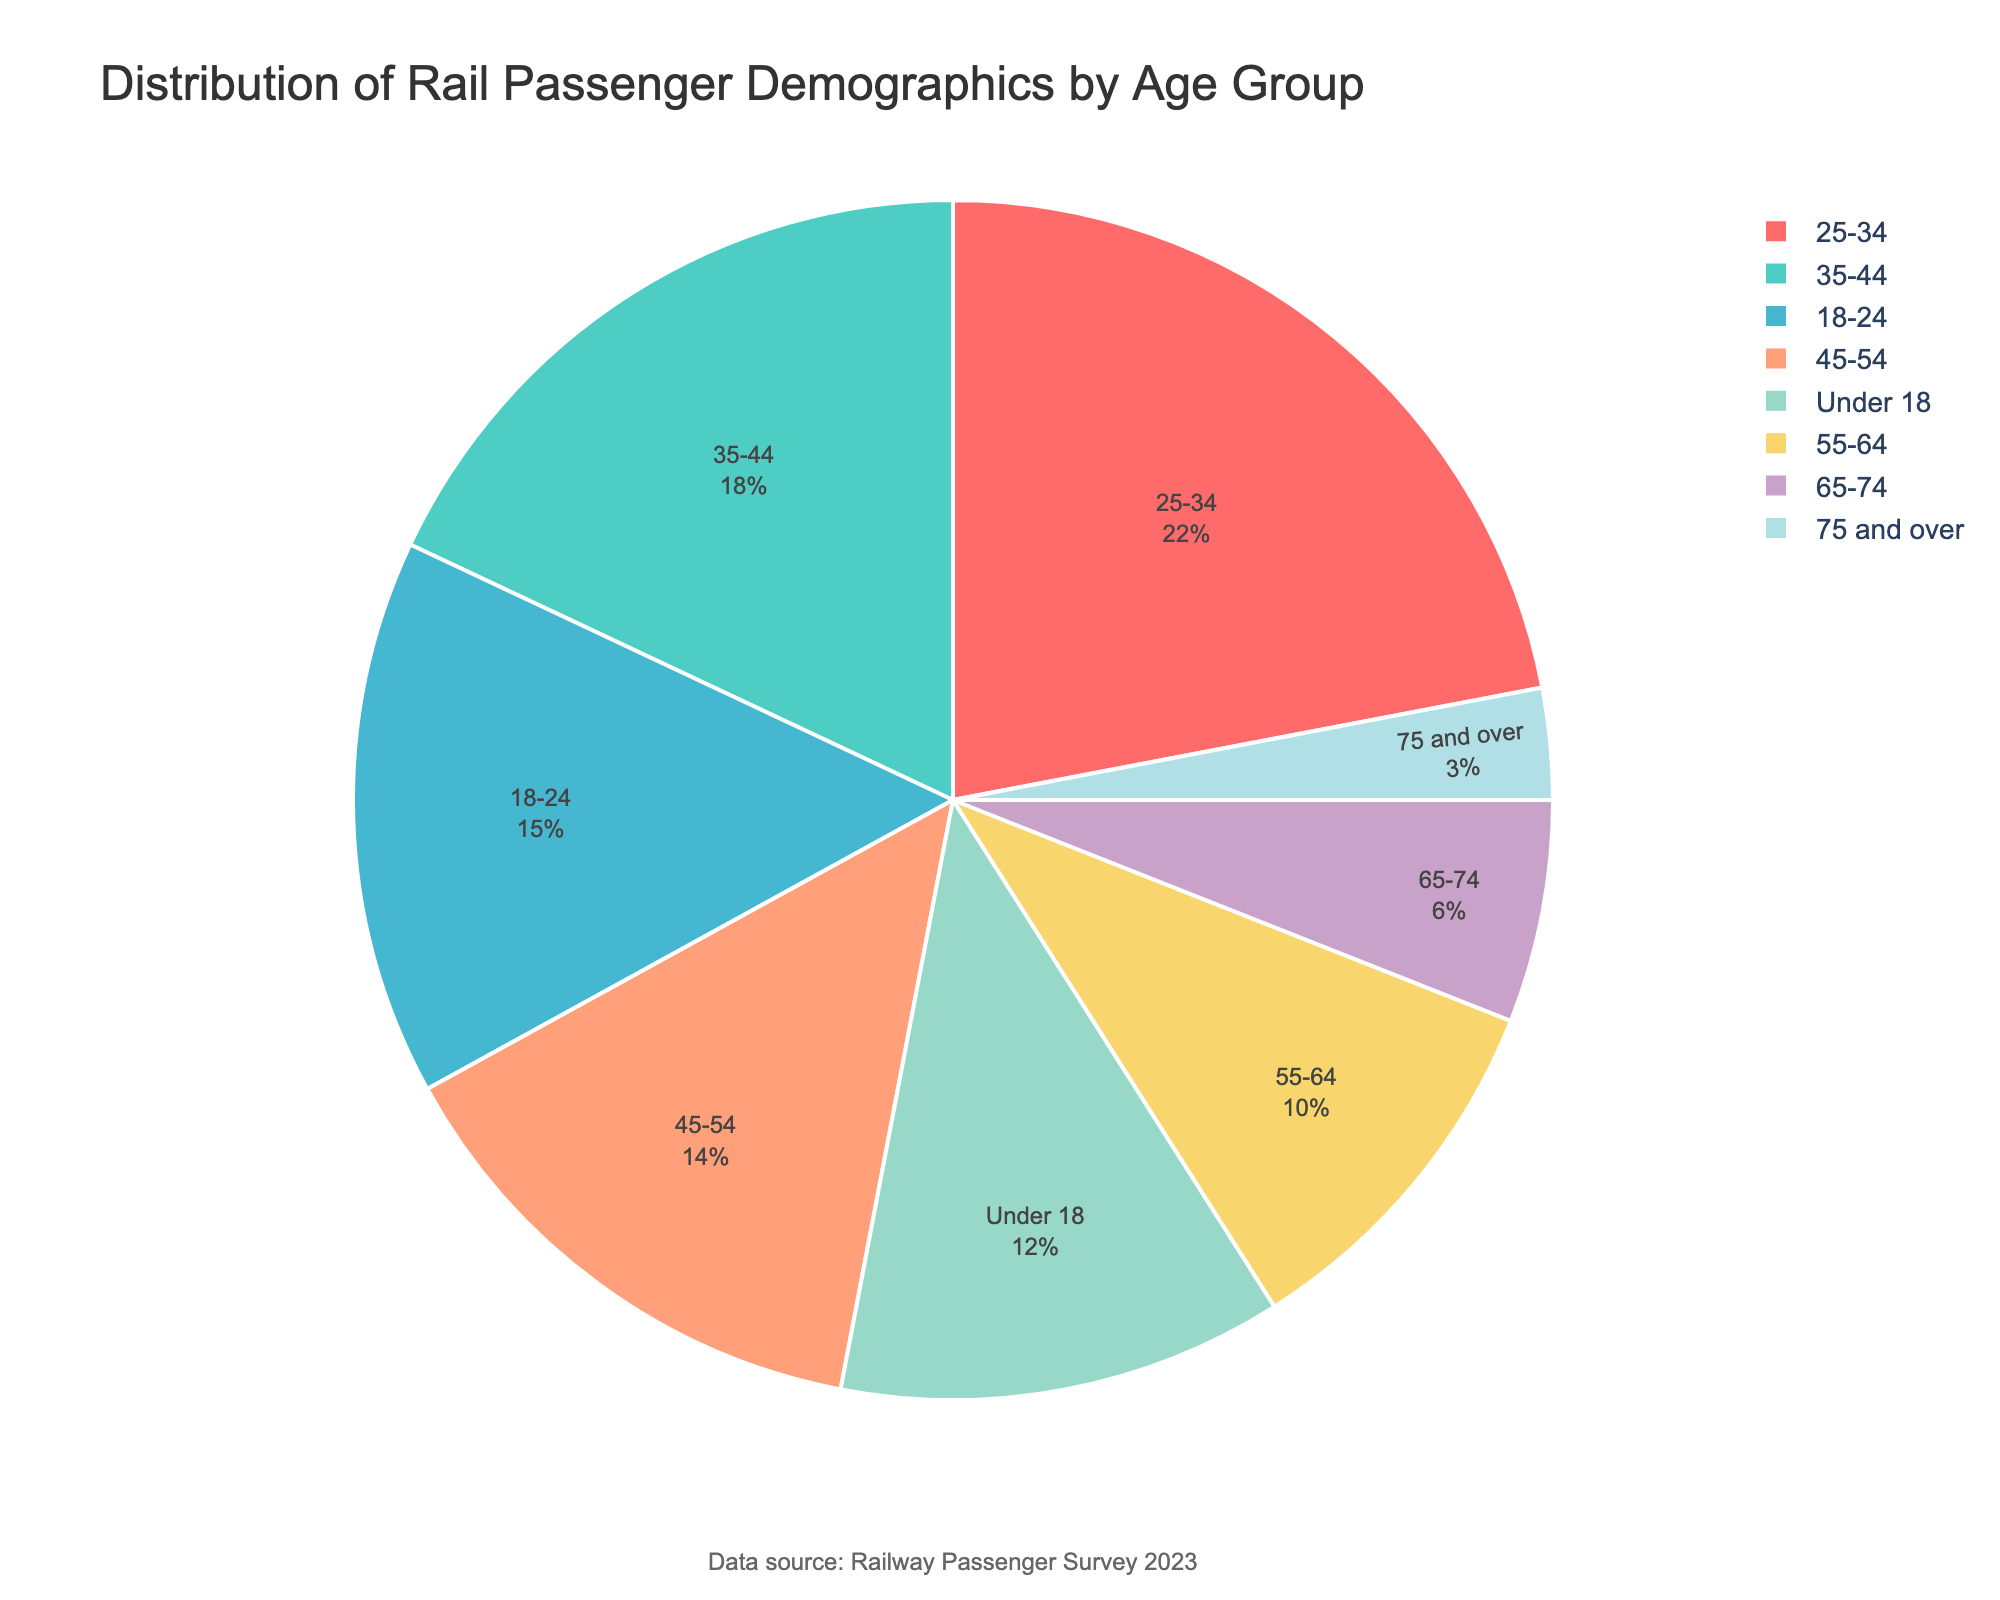What age group has the highest percentage of rail passengers? By looking at the figure, the segment labeled '25-34' is the largest, which indicates the highest percentage.
Answer: 25-34 What is the combined percentage of rail passengers aged 55 and above? To find this, sum the percentages of the age groups '55-64' (10), '65-74' (6), and '75 and over' (3). So, 10 + 6 + 3 = 19.
Answer: 19 Is the percentage of passengers aged 18-24 greater than the percentage of passengers aged 45-54? Compare the percentages: 18-24 has 15% and 45-54 has 14%. Since 15% is greater than 14%, the answer is yes.
Answer: Yes Which age group has the smallest percentage of rail passengers? The smallest segment in the figure is labeled '75 and over' with 3%.
Answer: 75 and over How does the percentage of passengers under 18 compare to the percentage of passengers aged 55-64? The percentage for 'Under 18' is 12%, and for '55-64' it is 10%. Since 12% is greater than 10%, the percentage of passengers under 18 is higher.
Answer: Greater What is the combined percentage of rail passengers aged 25-44? Sum the percentages of the age groups '25-34' (22) and '35-44' (18). So, 22 + 18 = 40.
Answer: 40 Which age groups together constitute exactly 21% of the rail passengers? By inspecting the figure, the groups '55-64' and '65-74' have percentages of 10% and 6%, and '75 and over' has 3%. Summing these, we get 10 + 6 + 3 = 19%. Adding 'Under 18' (12%) to this is too much as it totals to 31%. Thus, the exact combination is '55-64' + '75 and over' = 10 + 3% = 13% or '18-24' (15%). Therefore, '45-54' 14% + '75 and over' 3% equals 17% also possible.
Answer: 19%, 31% 